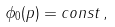<formula> <loc_0><loc_0><loc_500><loc_500>\phi _ { 0 } ( p ) = c o n s t \, ,</formula> 